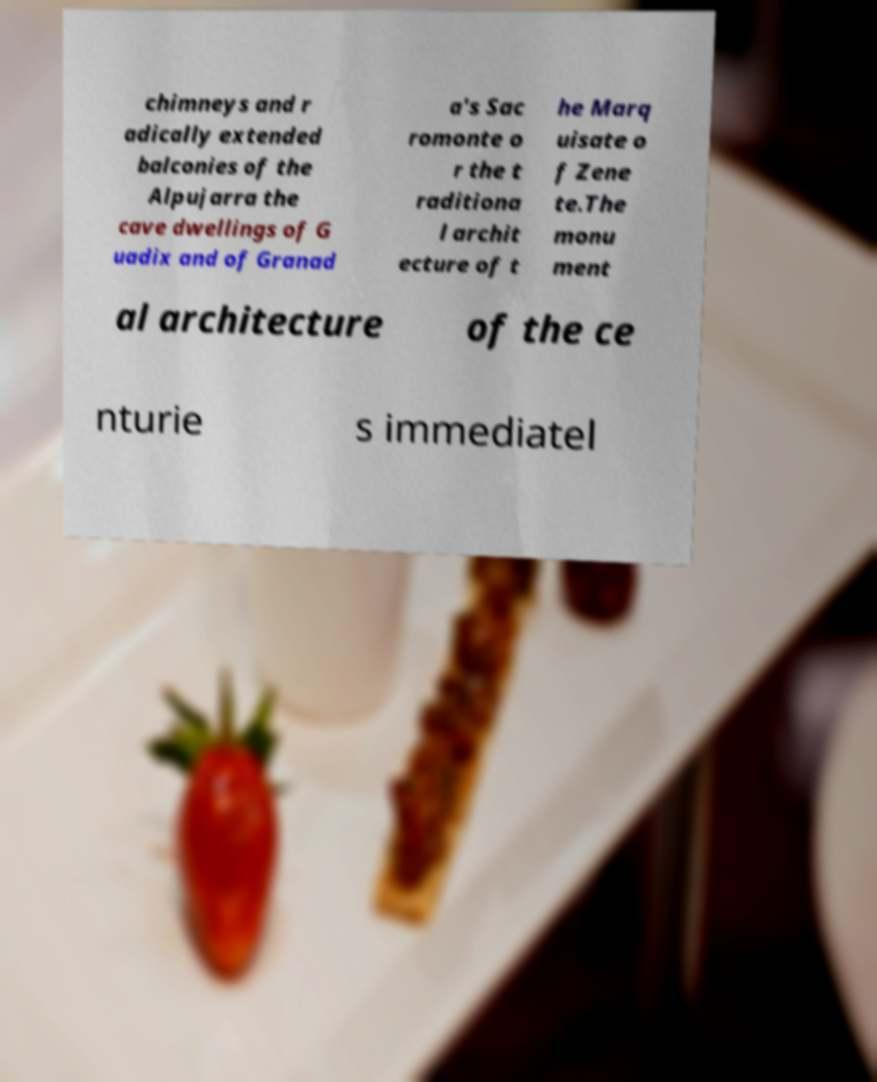For documentation purposes, I need the text within this image transcribed. Could you provide that? chimneys and r adically extended balconies of the Alpujarra the cave dwellings of G uadix and of Granad a's Sac romonte o r the t raditiona l archit ecture of t he Marq uisate o f Zene te.The monu ment al architecture of the ce nturie s immediatel 